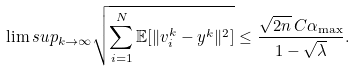Convert formula to latex. <formula><loc_0><loc_0><loc_500><loc_500>\lim s u p _ { k \to \infty } \sqrt { \sum _ { i = 1 } ^ { N } \mathbb { E } [ \| v _ { i } ^ { k } - y ^ { k } \| ^ { 2 } ] } \leq \frac { \sqrt { 2 n } \, C \alpha _ { \max } } { 1 - \sqrt { \lambda } } .</formula> 